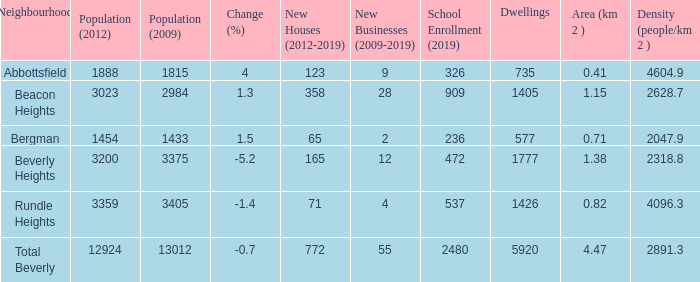What is the density of an area that is 1.38km and has a population more than 12924? 0.0. 